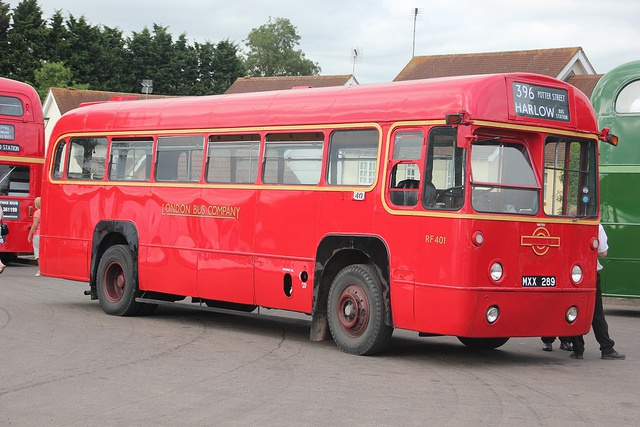Describe the objects in this image and their specific colors. I can see bus in gray, red, salmon, and darkgray tones, bus in gray, darkgreen, teal, darkgray, and lightgray tones, bus in gray, salmon, brown, black, and darkgray tones, people in gray, black, lavender, and darkgray tones, and people in gray, darkgray, brown, salmon, and lightpink tones in this image. 